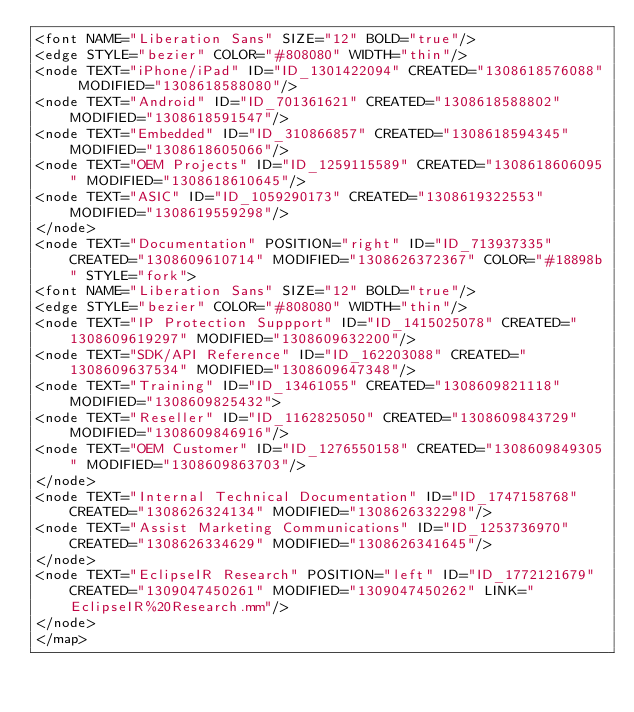<code> <loc_0><loc_0><loc_500><loc_500><_ObjectiveC_><font NAME="Liberation Sans" SIZE="12" BOLD="true"/>
<edge STYLE="bezier" COLOR="#808080" WIDTH="thin"/>
<node TEXT="iPhone/iPad" ID="ID_1301422094" CREATED="1308618576088" MODIFIED="1308618588080"/>
<node TEXT="Android" ID="ID_701361621" CREATED="1308618588802" MODIFIED="1308618591547"/>
<node TEXT="Embedded" ID="ID_310866857" CREATED="1308618594345" MODIFIED="1308618605066"/>
<node TEXT="OEM Projects" ID="ID_1259115589" CREATED="1308618606095" MODIFIED="1308618610645"/>
<node TEXT="ASIC" ID="ID_1059290173" CREATED="1308619322553" MODIFIED="1308619559298"/>
</node>
<node TEXT="Documentation" POSITION="right" ID="ID_713937335" CREATED="1308609610714" MODIFIED="1308626372367" COLOR="#18898b" STYLE="fork">
<font NAME="Liberation Sans" SIZE="12" BOLD="true"/>
<edge STYLE="bezier" COLOR="#808080" WIDTH="thin"/>
<node TEXT="IP Protection Suppport" ID="ID_1415025078" CREATED="1308609619297" MODIFIED="1308609632200"/>
<node TEXT="SDK/API Reference" ID="ID_162203088" CREATED="1308609637534" MODIFIED="1308609647348"/>
<node TEXT="Training" ID="ID_13461055" CREATED="1308609821118" MODIFIED="1308609825432">
<node TEXT="Reseller" ID="ID_1162825050" CREATED="1308609843729" MODIFIED="1308609846916"/>
<node TEXT="OEM Customer" ID="ID_1276550158" CREATED="1308609849305" MODIFIED="1308609863703"/>
</node>
<node TEXT="Internal Technical Documentation" ID="ID_1747158768" CREATED="1308626324134" MODIFIED="1308626332298"/>
<node TEXT="Assist Marketing Communications" ID="ID_1253736970" CREATED="1308626334629" MODIFIED="1308626341645"/>
</node>
<node TEXT="EclipseIR Research" POSITION="left" ID="ID_1772121679" CREATED="1309047450261" MODIFIED="1309047450262" LINK="EclipseIR%20Research.mm"/>
</node>
</map>
</code> 